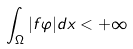<formula> <loc_0><loc_0><loc_500><loc_500>\int _ { \Omega } | f \varphi | d x < + \infty</formula> 